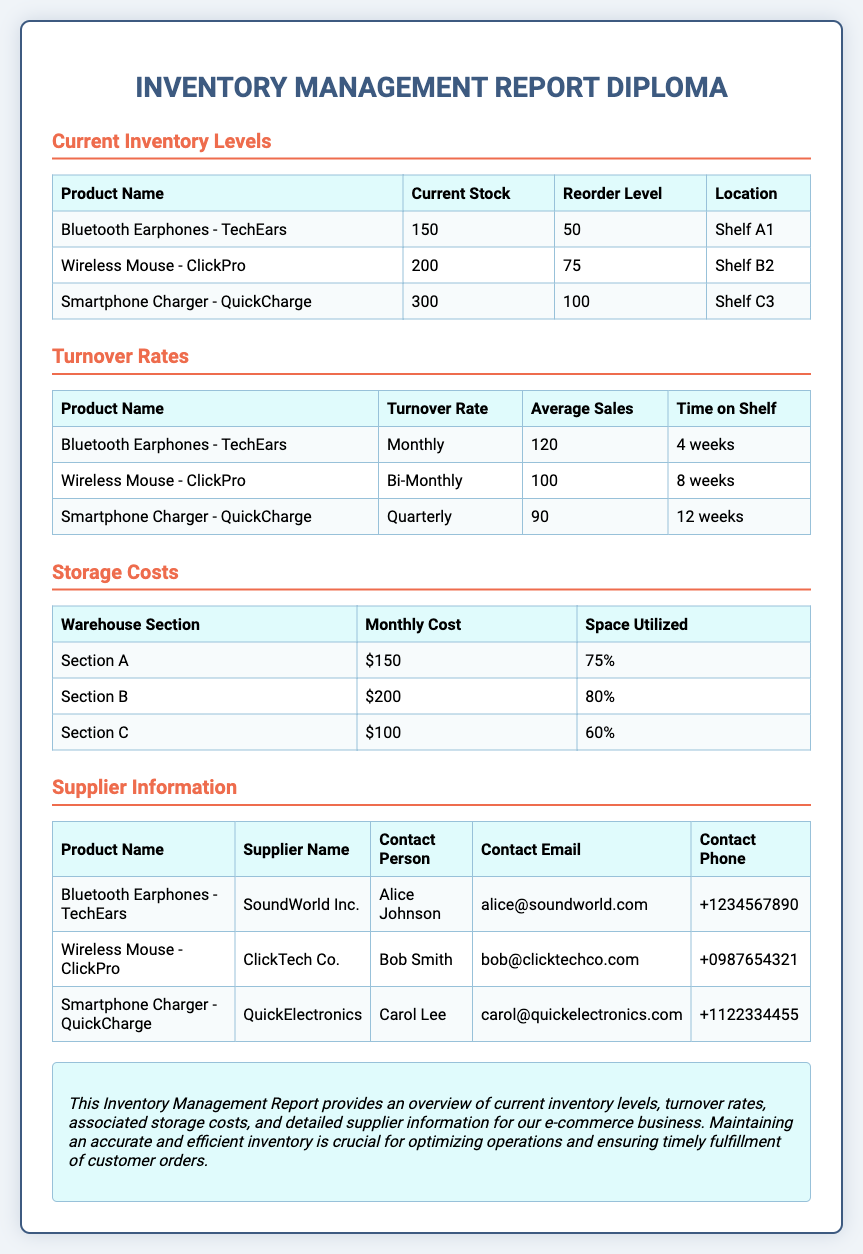What is the current stock of Bluetooth Earphones? The current stock is listed in the document's inventory section with the Bluetooth Earphones having a stock of 150 units.
Answer: 150 What is the reorder level for the Wireless Mouse? The reorder level is specified in the inventory section of the report as the minimum stock required, which for the Wireless Mouse is 75 units.
Answer: 75 What is the turnover rate for the Smartphone Charger? The turnover rate is computed in the report, showing that the Smartphone Charger has a turnover rate of quarterly.
Answer: Quarterly How much is the monthly storage cost for Section B? The storage costs are detailed in a table, with Section B having a monthly storage cost of $200.
Answer: $200 Who is the contact person for the supplier of Bluetooth Earphones? The contact person is provided in the supplier information section, identified as Alice Johnson for the Bluetooth Earphones.
Answer: Alice Johnson Which product has the highest current stock? The comparison of current stocks in the inventory section reveals that the product with the highest stock is Smartphone Charger.
Answer: Smartphone Charger What percentage of space is utilized in Section C? The space utilized is mentioned, showing that Section C has 60% utilization of its storage space.
Answer: 60% Which supplier corresponds to the Wireless Mouse? The supplier information table identifies ClickTech Co. as the supplier for the Wireless Mouse.
Answer: ClickTech Co What is the average sales figure for Bluetooth Earphones? The average sales figure for Bluetooth Earphones is stated in the turnover rates section of the report as 120 units.
Answer: 120 